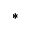<formula> <loc_0><loc_0><loc_500><loc_500>\ast</formula> 